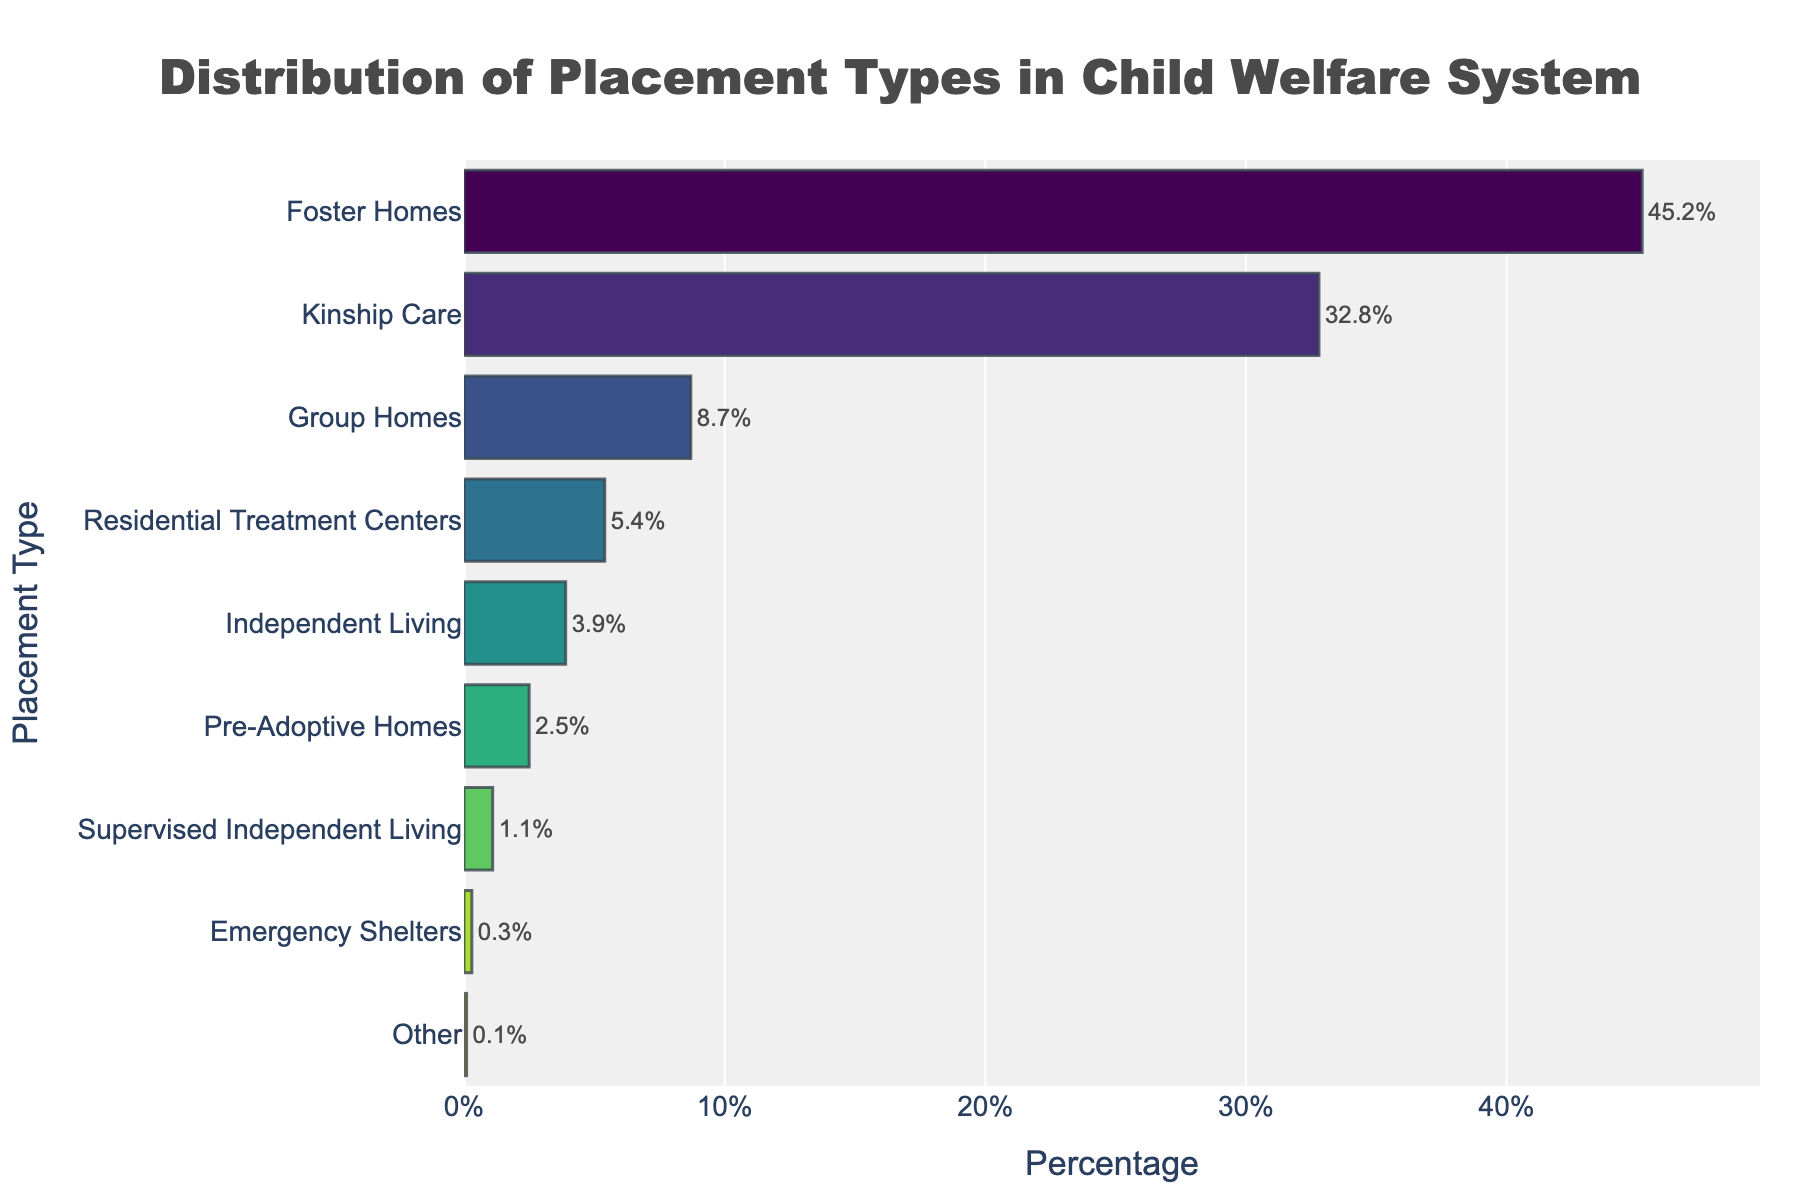Which placement type has the highest percentage? The placement type with the highest percentage is determined by comparing the bar lengths. The longest bar corresponds to Foster Homes.
Answer: Foster Homes Which placement type has the lowest percentage? The placement type with the lowest percentage is identified by the shortest bar. The shortest bar corresponds to Other.
Answer: Other What is the combined percentage of Foster Homes and Kinship Care? Add the percentages of Foster Homes (45.2%) and Kinship Care (32.8%). The sum is 45.2 + 32.8 = 78.
Answer: 78% How many placement types have a percentage below 10%? Count the bars with values under 10%. Group Homes (8.7%), Residential Treatment Centers (5.4%), Independent Living (3.9%), Pre-Adoptive Homes (2.5%), Supervised Independent Living (1.1%), Emergency Shelters (0.3%), and Other (0.1%) make a total of 7.
Answer: 7 Compare the percentage of Kinship Care to Group Homes. Kinship Care has a higher percentage (32.8%) compared to Group Homes (8.7%).
Answer: Kinship Care Which placement type has a percentage closest to 5%? Compare all percentages to 5%. Residential Treatment Centers at 5.4% is the closest.
Answer: Residential Treatment Centers What is the percentage difference between Foster Homes and Pre-Adoptive Homes? Subtract the percentage of Pre-Adoptive Homes (2.5%) from Foster Homes (45.2%). The difference is 45.2 - 2.5 = 42.7.
Answer: 42.7% What is the median percentage of all placement types? Sort the percentages and find the middle value(s). Sorted percentages: 0.1, 0.3, 1.1, 2.5, 3.9, 5.4, 8.7, 32.8, 45.2. The median is between 5.4 and 8.7, so (5.4 + 8.7)/2 = 7.05.
Answer: 7.05% Which three placement types have intermediate percentages between 1.1% and 5.4%? Identify the placement types with percentages between 1.1% and 5.4%. They are Pre-Adoptive Homes (2.5%) and Independent Living (3.9%).
Answer: Pre-Adoptive Homes, Independent Living What is the visual color pattern used in the bar chart? The bars are colored using a gradient from the Viridis colorscale, moving from darker to lighter shades.
Answer: Viridis colorscale 